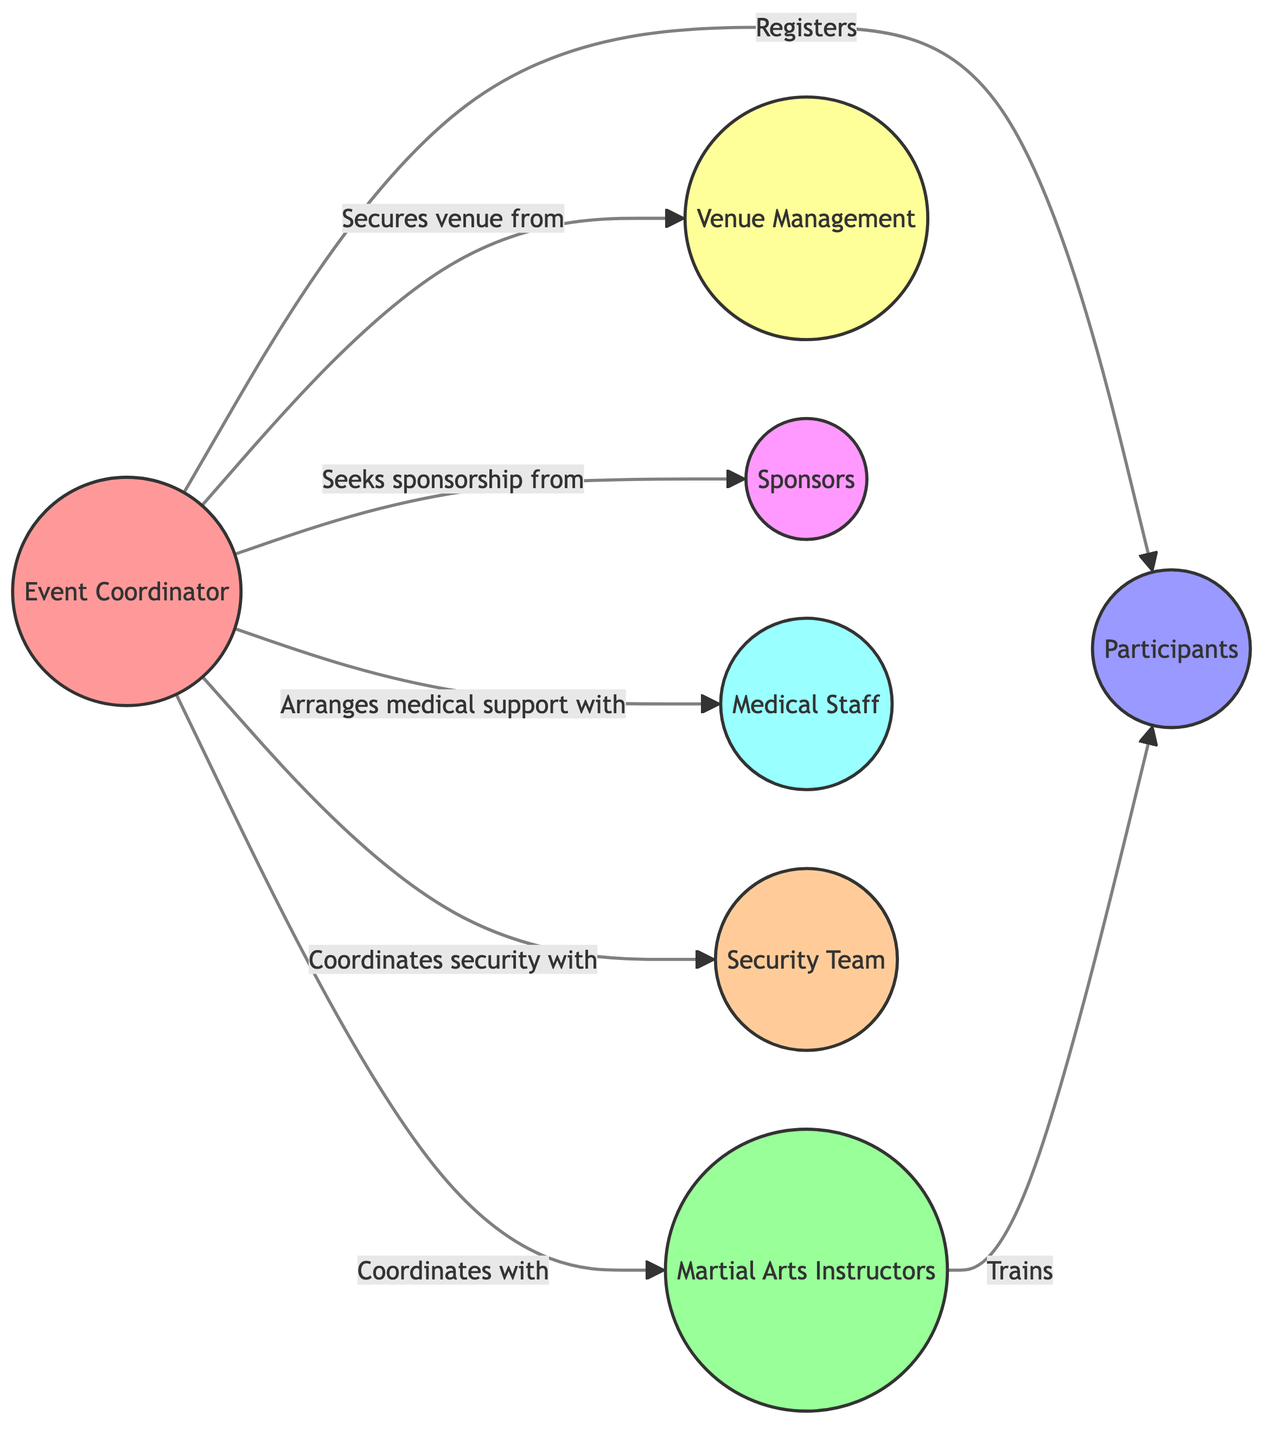What is the role of node '1'? The node labeled '1' is the "Event Coordinator," indicating its primary role in the network diagram.
Answer: Event Coordinator How many nodes are there in total? By counting the nodes listed in the data, we find seven distinct roles or entities represented, which are the 'Event Coordinator', 'Martial Arts Instructors', 'Participants', 'Venue Management', 'Sponsors', 'Medical Staff', and 'Security Team'.
Answer: 7 Who does the Event Coordinator coordinate with? The Event Coordinator (node '1') has direct connections to nodes '2' (Martial Arts Instructors), '4' (Venue Management), '5' (Sponsors), '6' (Medical Staff), and '7' (Security Team), indicating collaboration with these roles.
Answer: Martial Arts Instructors, Venue Management, Sponsors, Medical Staff, Security Team What is the relationship between Participants and Martial Arts Instructors? The edge between '3' (Participants) and '2' (Martial Arts Instructors) is labeled "Trains," showing that Instructors provide training to Participants.
Answer: Trains How many edges are connected to the Event Coordinator? The Event Coordinator (node '1') has six outgoing edges representing its connections to the other roles, indicating the number of direct interactions it maintains within the event diagram.
Answer: 6 What type of relationship exists between the Event Coordinator and Sponsors? The edge between '1' (Event Coordinator) and '5' (Sponsors) is labeled "Seeks sponsorship from," illustrating that the relationship is about obtaining financial or material support for the event.
Answer: Seeks sponsorship from Which role is responsible for training the Participants? Analyzing the connection, the Martial Arts Instructors (node '2') is the role that directly engages with Participants (node '3') to provide training.
Answer: Martial Arts Instructors Which team does the Event Coordinator coordinate security with? Referring to the connection between node '1' (Event Coordinator) and node '7' (Security Team), the edge indicates that the Coordinator works in collaboration with this team for safety and security measures during events.
Answer: Security Team 